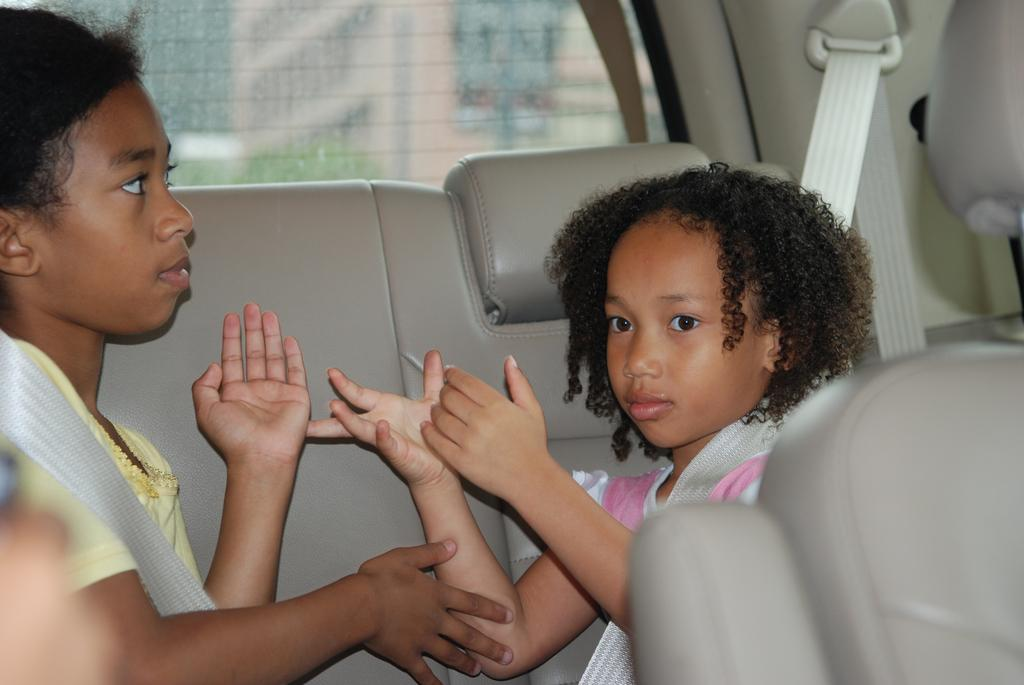What is the location of the girls in the image? The girls are seated on the back seat of a car. What can be seen through the car's glass? There is a building visible from the car's glass. What type of theory is being discussed by the girls in the image? There is no indication in the image that the girls are discussing any theory. 